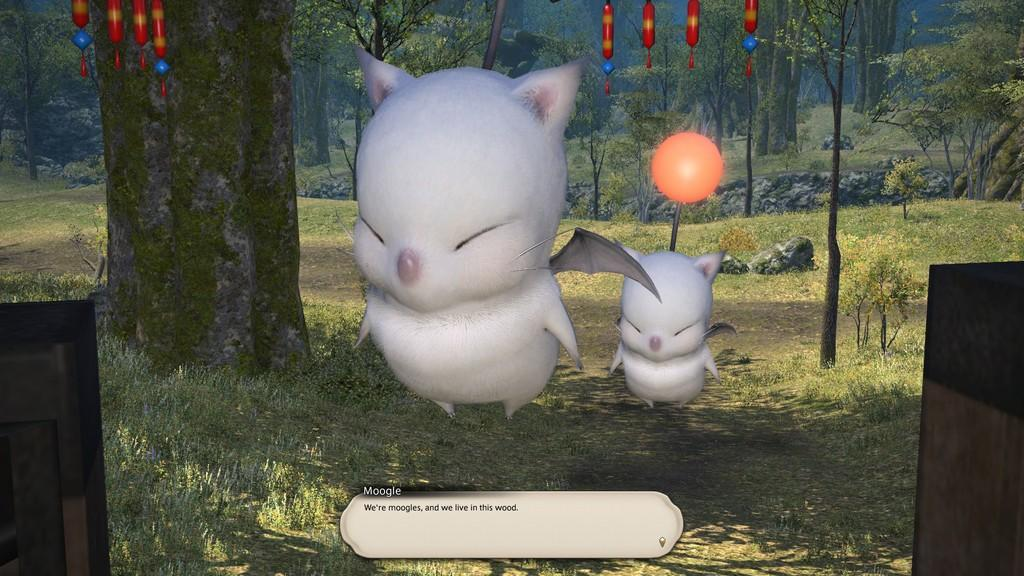What type of image is being described? The image is animated. What animals can be seen in the image? There are two white birds in the image. What color objects are present in the image? There are red objects in the image. What can be seen in the background of the image? There are many trees in the background of the image. How many legs can be seen on the box in the image? There is no box present in the image, so it is not possible to determine the number of legs on a box. 